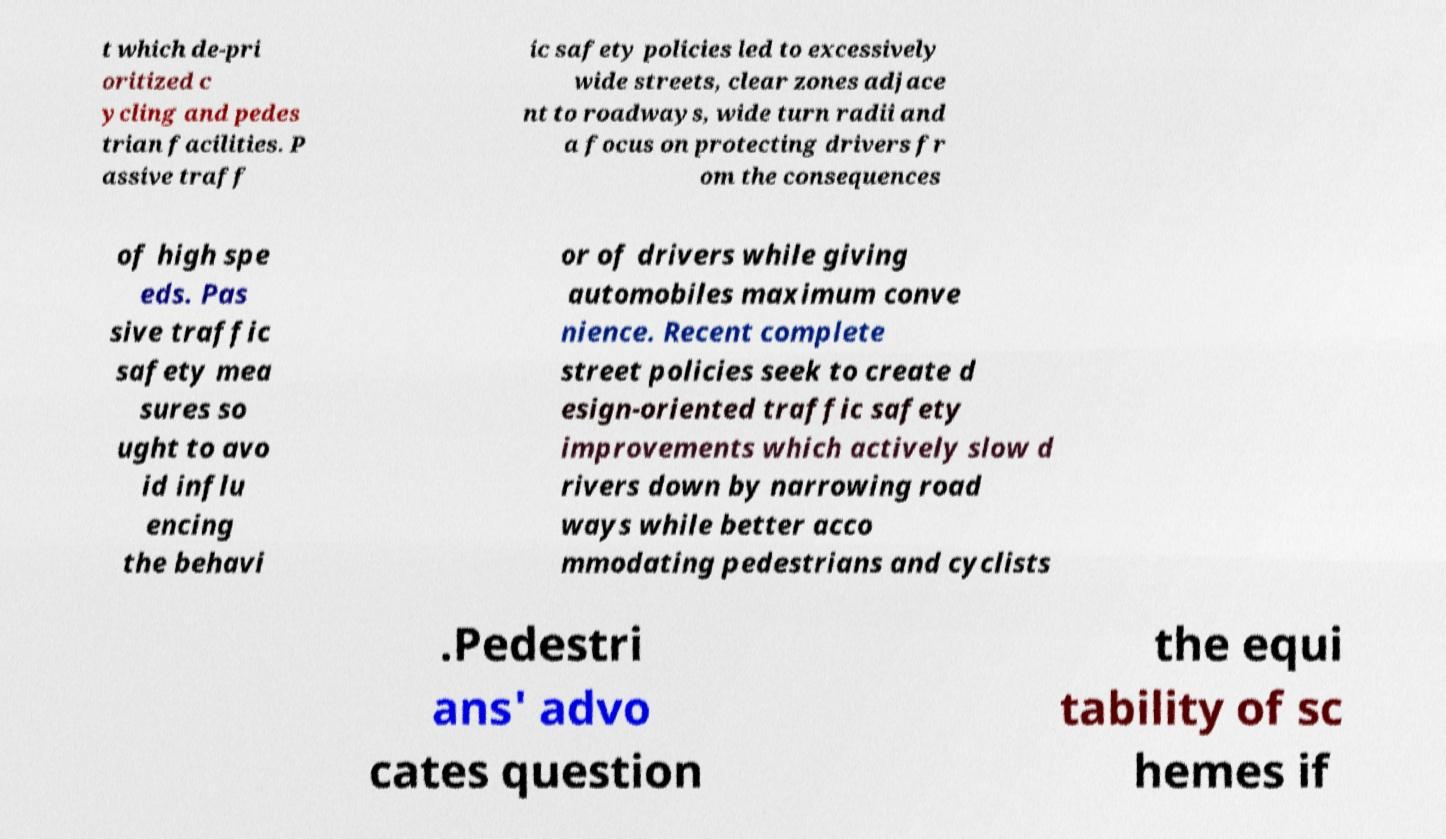For documentation purposes, I need the text within this image transcribed. Could you provide that? t which de-pri oritized c ycling and pedes trian facilities. P assive traff ic safety policies led to excessively wide streets, clear zones adjace nt to roadways, wide turn radii and a focus on protecting drivers fr om the consequences of high spe eds. Pas sive traffic safety mea sures so ught to avo id influ encing the behavi or of drivers while giving automobiles maximum conve nience. Recent complete street policies seek to create d esign-oriented traffic safety improvements which actively slow d rivers down by narrowing road ways while better acco mmodating pedestrians and cyclists .Pedestri ans' advo cates question the equi tability of sc hemes if 